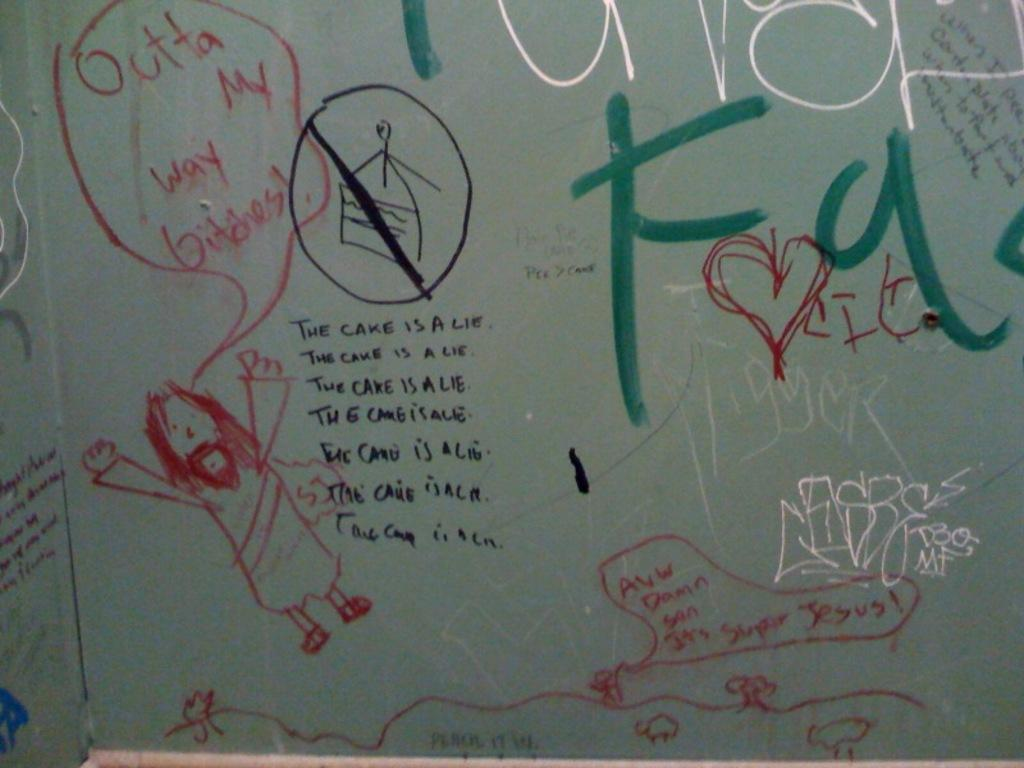<image>
Relay a brief, clear account of the picture shown. Someone has written "the cake is a lie" on a whiteboard next to a drawing of a man. 